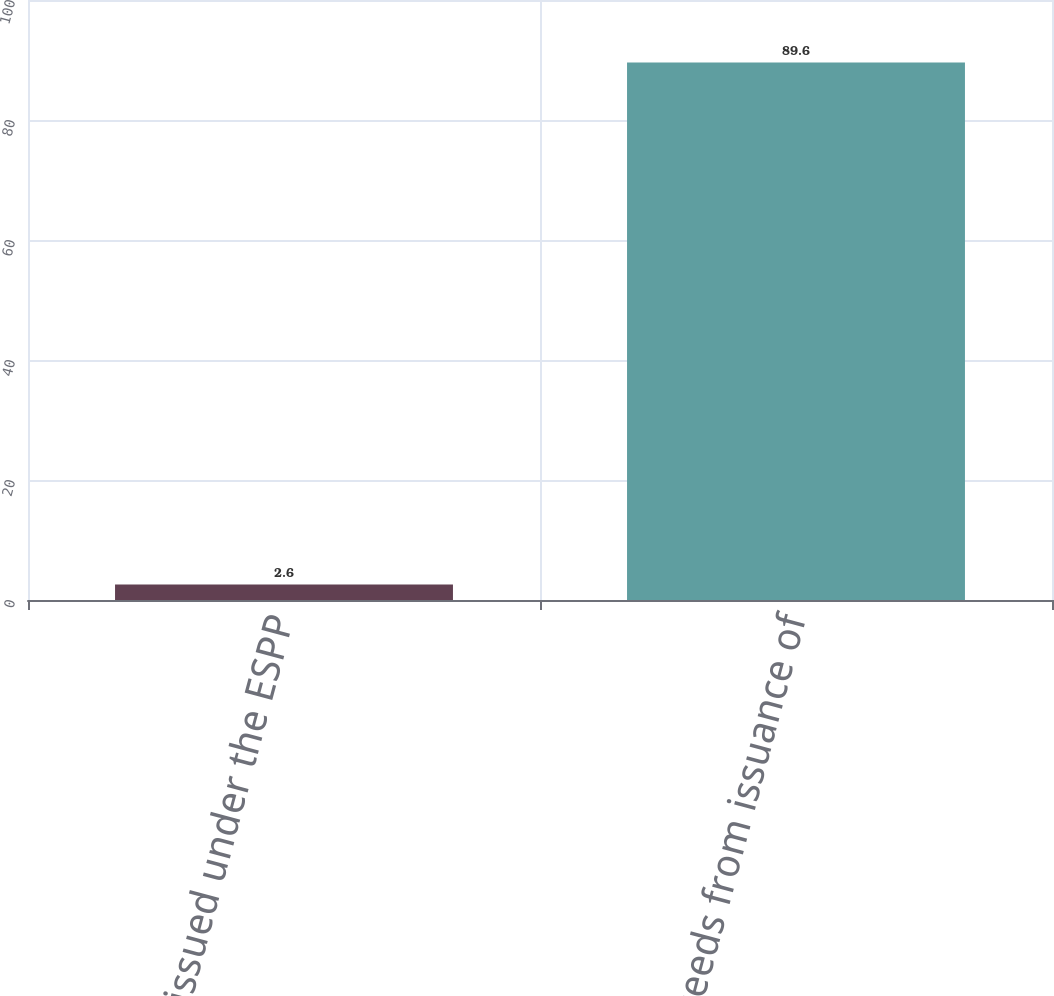Convert chart. <chart><loc_0><loc_0><loc_500><loc_500><bar_chart><fcel>Shares issued under the ESPP<fcel>Proceeds from issuance of<nl><fcel>2.6<fcel>89.6<nl></chart> 